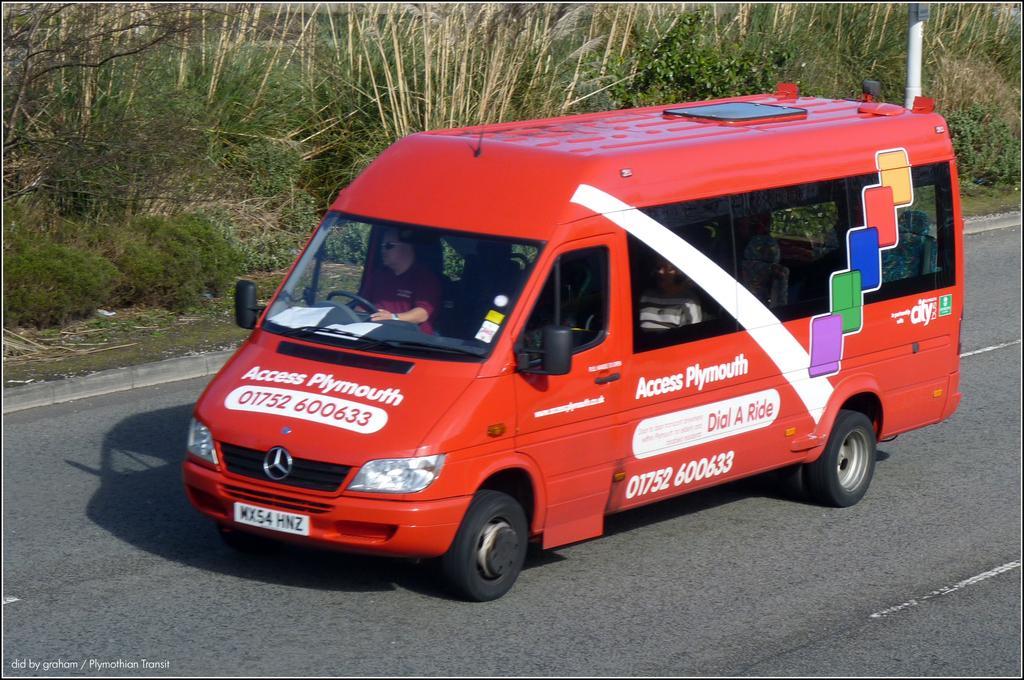Can you describe this image briefly? In the center of the image we can see person in bus on the road. In the background we can see trees, plants and pole. 